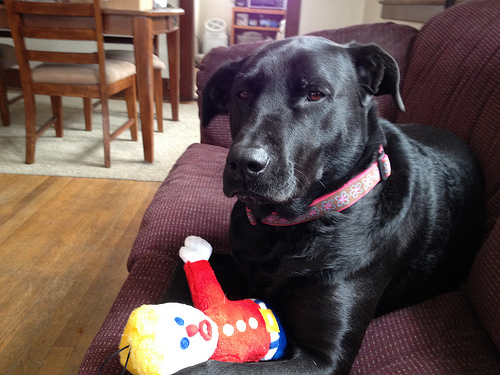<image>
Is the dog on the floor? No. The dog is not positioned on the floor. They may be near each other, but the dog is not supported by or resting on top of the floor. Is there a doll in front of the dog? Yes. The doll is positioned in front of the dog, appearing closer to the camera viewpoint. 